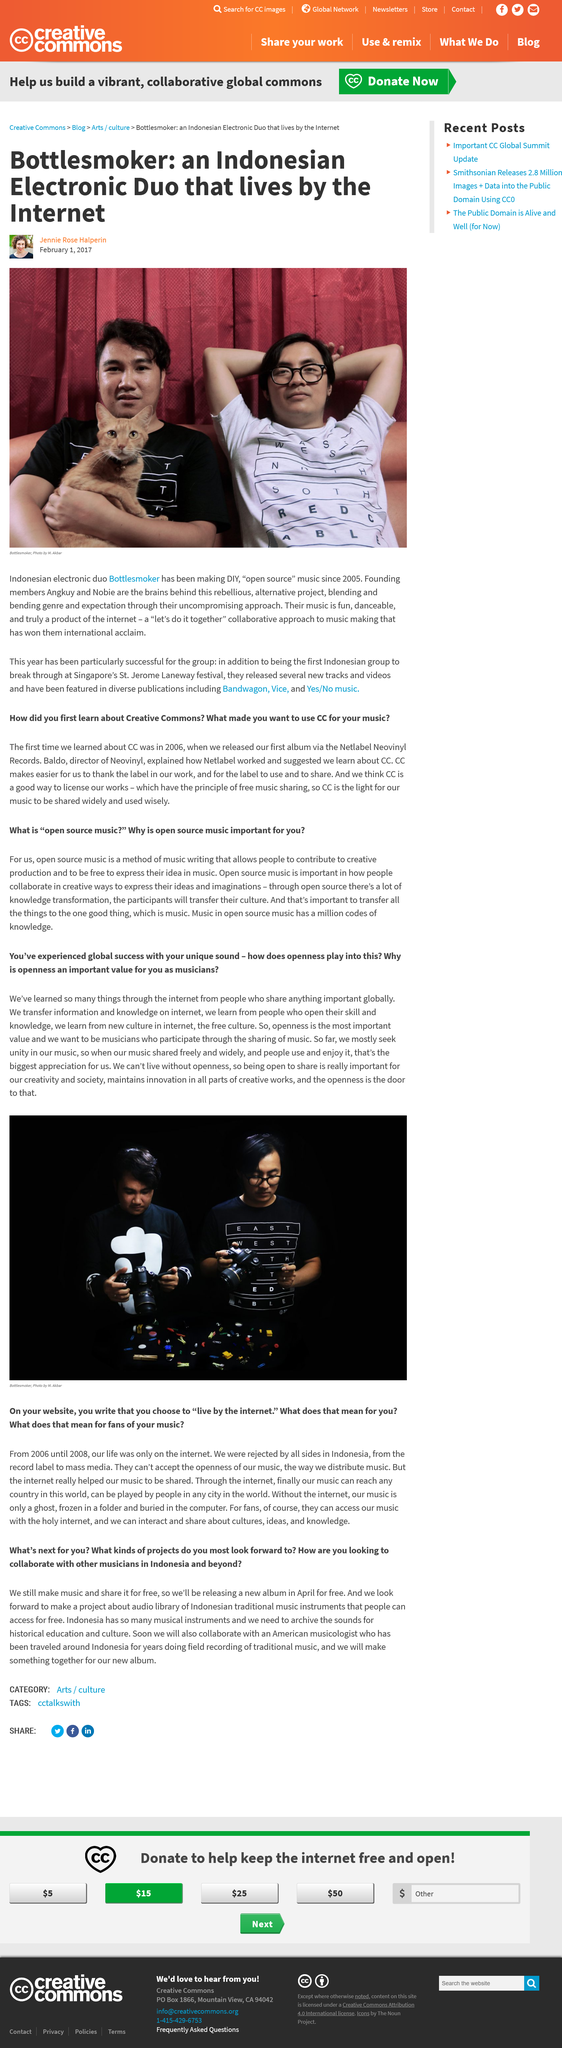Indicate a few pertinent items in this graphic. Open source music allows individuals to express their ideas freely and without restriction in the realm of music. The two individuals in question are musicians by profession. It is imperative that individuals are open to sharing in order to foster their creativity and contribute to a thriving society. Bottlesmoker is the name of an Indonesian electronic duo. It is predicted that they will be collaborating with an American musicologist in the near future. 